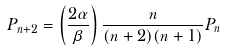Convert formula to latex. <formula><loc_0><loc_0><loc_500><loc_500>P _ { n + 2 } = \left ( \frac { 2 \alpha } { \beta } \right ) \frac { n } { ( n + 2 ) ( n + 1 ) } P _ { n }</formula> 